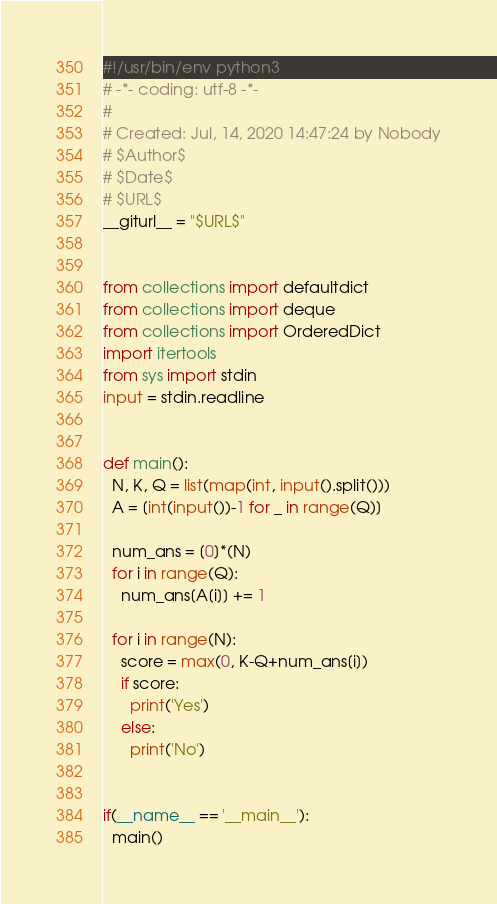Convert code to text. <code><loc_0><loc_0><loc_500><loc_500><_Python_>#!/usr/bin/env python3
# -*- coding: utf-8 -*-
#
# Created: Jul, 14, 2020 14:47:24 by Nobody
# $Author$
# $Date$
# $URL$
__giturl__ = "$URL$"


from collections import defaultdict
from collections import deque
from collections import OrderedDict
import itertools
from sys import stdin
input = stdin.readline


def main():
  N, K, Q = list(map(int, input().split()))
  A = [int(input())-1 for _ in range(Q)]

  num_ans = [0]*(N)
  for i in range(Q):
    num_ans[A[i]] += 1

  for i in range(N):
    score = max(0, K-Q+num_ans[i])
    if score:
      print('Yes')
    else:
      print('No')


if(__name__ == '__main__'):
  main()
</code> 